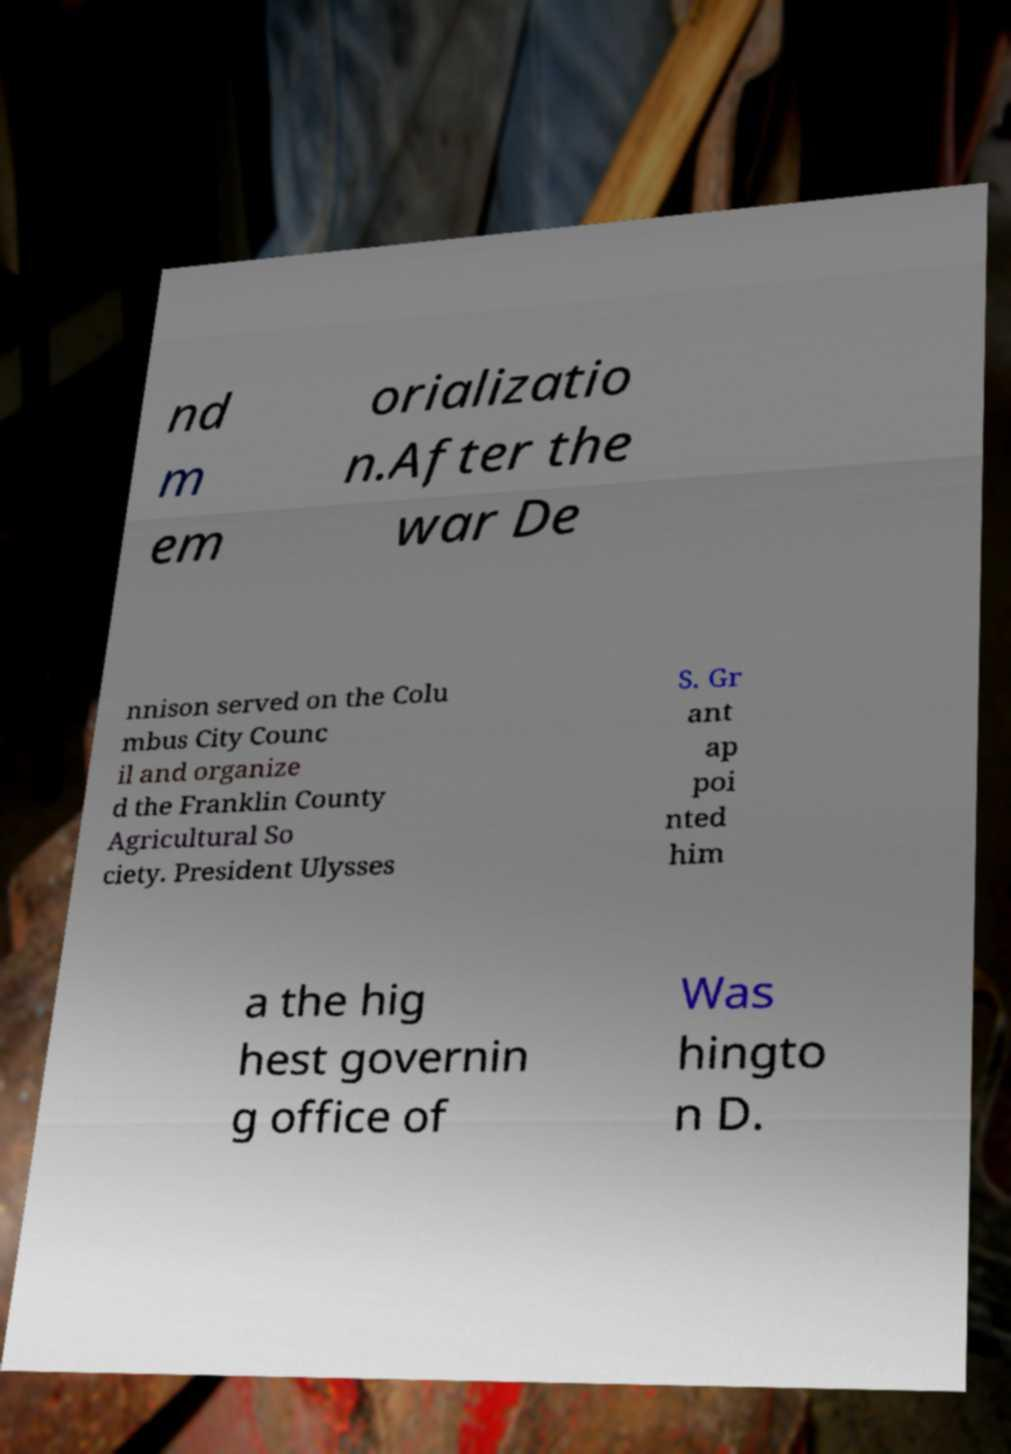Please identify and transcribe the text found in this image. nd m em orializatio n.After the war De nnison served on the Colu mbus City Counc il and organize d the Franklin County Agricultural So ciety. President Ulysses S. Gr ant ap poi nted him a the hig hest governin g office of Was hingto n D. 